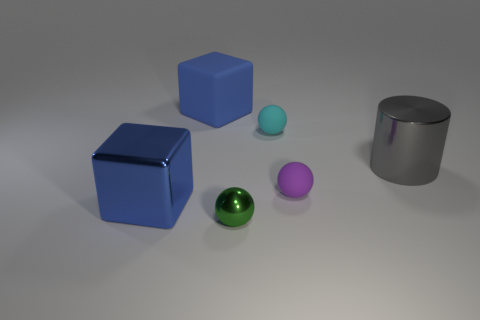The matte object that is the same color as the big metal block is what size?
Your answer should be very brief. Large. What number of metal balls are the same size as the gray metallic thing?
Provide a succinct answer. 0. Are there an equal number of cyan things that are to the left of the blue matte object and big purple metal objects?
Provide a succinct answer. Yes. What number of things are to the left of the small cyan rubber ball and to the right of the metallic cube?
Give a very brief answer. 2. What size is the purple ball that is the same material as the small cyan object?
Provide a short and direct response. Small. What number of large blue things are the same shape as the big gray thing?
Your answer should be compact. 0. Is the number of tiny purple things that are in front of the small shiny sphere greater than the number of rubber blocks?
Your response must be concise. No. There is a big object that is both behind the small purple ball and on the left side of the small green thing; what shape is it?
Give a very brief answer. Cube. Does the metal block have the same size as the gray metal cylinder?
Your response must be concise. Yes. There is a small metallic ball; how many metallic spheres are in front of it?
Your answer should be very brief. 0. 